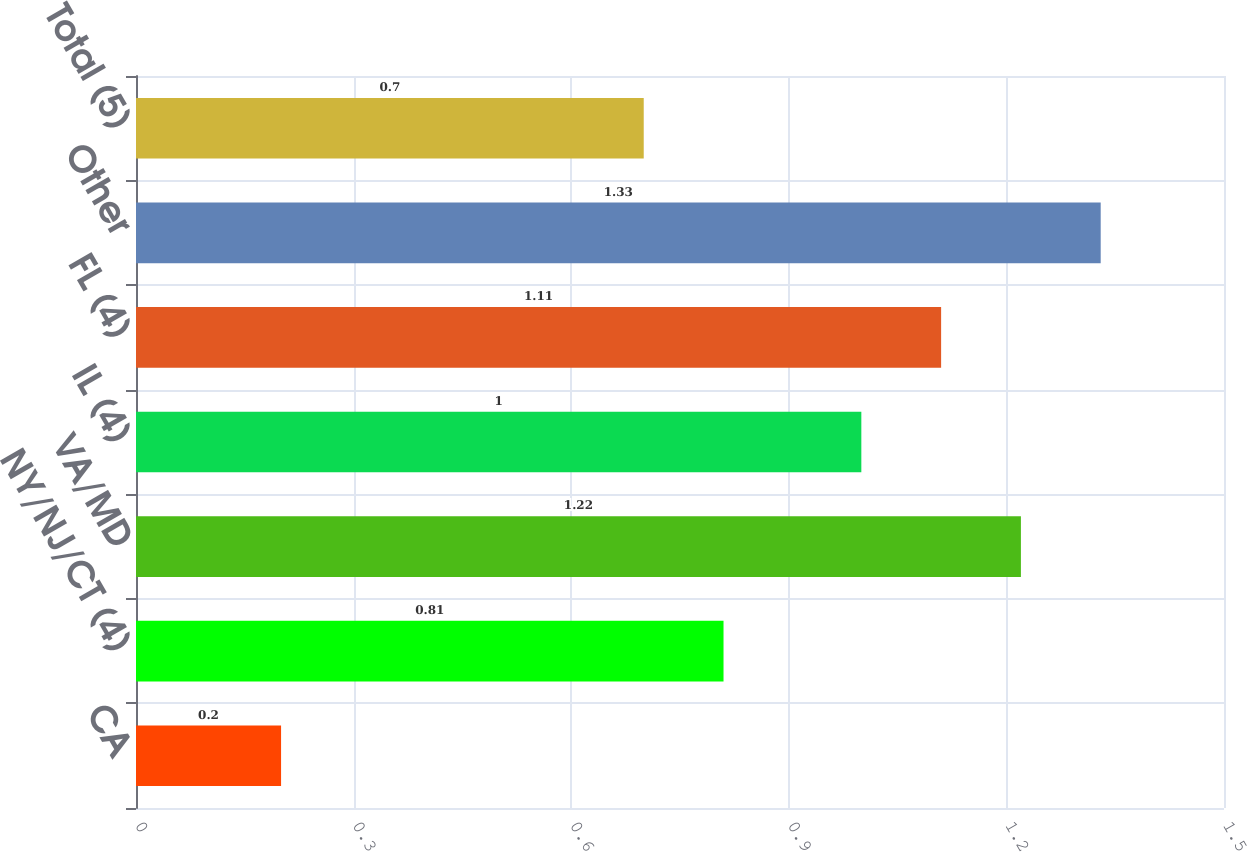Convert chart to OTSL. <chart><loc_0><loc_0><loc_500><loc_500><bar_chart><fcel>CA<fcel>NY/NJ/CT (4)<fcel>VA/MD<fcel>IL (4)<fcel>FL (4)<fcel>Other<fcel>Total (5)<nl><fcel>0.2<fcel>0.81<fcel>1.22<fcel>1<fcel>1.11<fcel>1.33<fcel>0.7<nl></chart> 